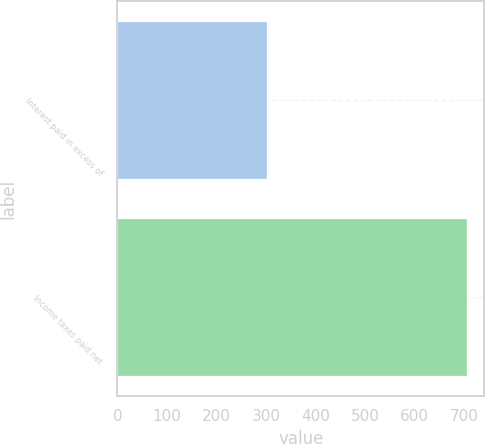<chart> <loc_0><loc_0><loc_500><loc_500><bar_chart><fcel>Interest paid in excess of<fcel>Income taxes paid net<nl><fcel>302<fcel>705<nl></chart> 